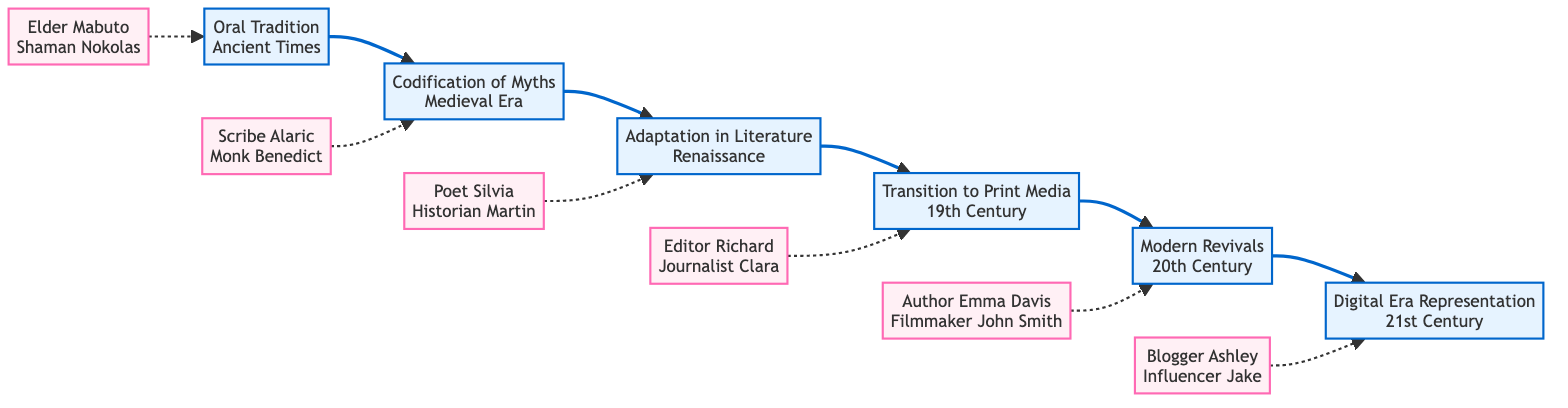What is the first element in the flowchart? The flowchart begins with the element "Oral Tradition," which is specified as the first node in the sequence.
Answer: Oral Tradition How many key figures are associated with "Transition to Print Media"? "Transition to Print Media" features two key figures listed as "Editor Richard" and "Journalist Clara." Hence, the count is two.
Answer: 2 What time period does "Modern Revivals" belong to? The time period associated with "Modern Revivals" is stated as the "20th Century," which is directly placed in the node.
Answer: 20th Century Which element follows "Adaptation in Literature"? According to the flow of the diagram, "Transition to Print Media" directly follows "Adaptation in Literature." This establishes the next sequential step within the flowchart.
Answer: Transition to Print Media Who are the key figures connected to "Codification of Myths"? The key figures associated with "Codification of Myths" are "Scribe Alaric" and "Monk Benedict," both listed in the diagram.
Answer: Scribe Alaric, Monk Benedict What is the last element in the flowchart? The final element in the flowchart is "Digital Era Representation," indicating the last stage in the chronological evolution of local folklore.
Answer: Digital Era Representation In which element does the key figure "Filmmaker John Smith" appear? "Filmmaker John Smith" is connected to the element "Modern Revivals," as indicated by the relationship in the flow and specifically mentioned under that node.
Answer: Modern Revivals How many total elements are shown in the flowchart? Five distinct elements are present in the flowchart, which can be counted: Oral Tradition, Codification of Myths, Adaptation in Literature, Transition to Print Media, Modern Revivals, and Digital Era Representation.
Answer: 6 What is the relationship between "Oral Tradition" and "Codification of Myths"? "Oral Tradition" leads into "Codification of Myths," indicating a direct progression or evolution from storytelling by village elders to the transcription of those tales onto scrolls. This relationship demonstrates a developmental transition in the folklore's documentation.
Answer: Leads to 